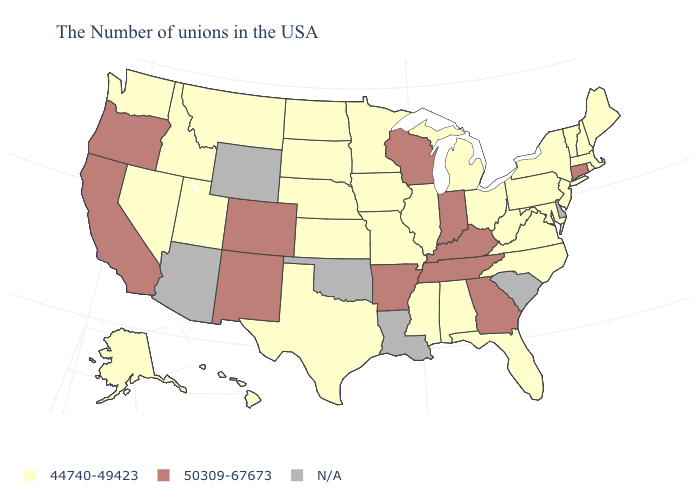What is the value of Ohio?
Write a very short answer. 44740-49423. Name the states that have a value in the range N/A?
Answer briefly. Delaware, South Carolina, Louisiana, Oklahoma, Wyoming, Arizona. What is the value of Maine?
Short answer required. 44740-49423. What is the value of Maine?
Be succinct. 44740-49423. Does Utah have the highest value in the USA?
Quick response, please. No. Name the states that have a value in the range N/A?
Keep it brief. Delaware, South Carolina, Louisiana, Oklahoma, Wyoming, Arizona. Name the states that have a value in the range N/A?
Quick response, please. Delaware, South Carolina, Louisiana, Oklahoma, Wyoming, Arizona. Name the states that have a value in the range 44740-49423?
Quick response, please. Maine, Massachusetts, Rhode Island, New Hampshire, Vermont, New York, New Jersey, Maryland, Pennsylvania, Virginia, North Carolina, West Virginia, Ohio, Florida, Michigan, Alabama, Illinois, Mississippi, Missouri, Minnesota, Iowa, Kansas, Nebraska, Texas, South Dakota, North Dakota, Utah, Montana, Idaho, Nevada, Washington, Alaska, Hawaii. Does Minnesota have the lowest value in the USA?
Short answer required. Yes. Does the first symbol in the legend represent the smallest category?
Give a very brief answer. Yes. Name the states that have a value in the range N/A?
Write a very short answer. Delaware, South Carolina, Louisiana, Oklahoma, Wyoming, Arizona. What is the value of Mississippi?
Be succinct. 44740-49423. Name the states that have a value in the range 44740-49423?
Be succinct. Maine, Massachusetts, Rhode Island, New Hampshire, Vermont, New York, New Jersey, Maryland, Pennsylvania, Virginia, North Carolina, West Virginia, Ohio, Florida, Michigan, Alabama, Illinois, Mississippi, Missouri, Minnesota, Iowa, Kansas, Nebraska, Texas, South Dakota, North Dakota, Utah, Montana, Idaho, Nevada, Washington, Alaska, Hawaii. Name the states that have a value in the range N/A?
Answer briefly. Delaware, South Carolina, Louisiana, Oklahoma, Wyoming, Arizona. 